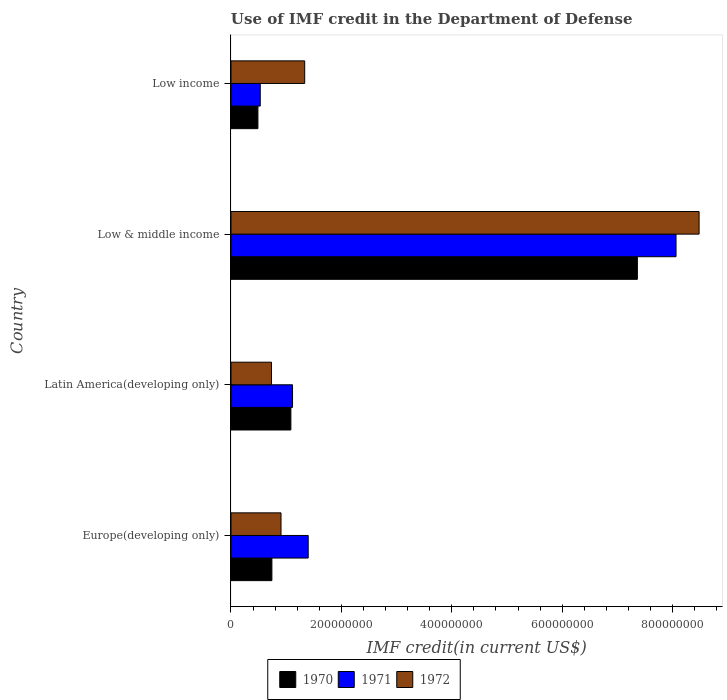How many different coloured bars are there?
Make the answer very short. 3. How many groups of bars are there?
Ensure brevity in your answer.  4. Are the number of bars on each tick of the Y-axis equal?
Your answer should be very brief. Yes. How many bars are there on the 2nd tick from the top?
Your response must be concise. 3. What is the label of the 4th group of bars from the top?
Your response must be concise. Europe(developing only). In how many cases, is the number of bars for a given country not equal to the number of legend labels?
Provide a succinct answer. 0. What is the IMF credit in the Department of Defense in 1970 in Low & middle income?
Your response must be concise. 7.36e+08. Across all countries, what is the maximum IMF credit in the Department of Defense in 1971?
Make the answer very short. 8.06e+08. Across all countries, what is the minimum IMF credit in the Department of Defense in 1971?
Give a very brief answer. 5.30e+07. In which country was the IMF credit in the Department of Defense in 1970 maximum?
Make the answer very short. Low & middle income. What is the total IMF credit in the Department of Defense in 1971 in the graph?
Provide a succinct answer. 1.11e+09. What is the difference between the IMF credit in the Department of Defense in 1971 in Latin America(developing only) and that in Low & middle income?
Provide a short and direct response. -6.95e+08. What is the difference between the IMF credit in the Department of Defense in 1970 in Europe(developing only) and the IMF credit in the Department of Defense in 1971 in Latin America(developing only)?
Your answer should be very brief. -3.74e+07. What is the average IMF credit in the Department of Defense in 1972 per country?
Offer a terse response. 2.86e+08. What is the difference between the IMF credit in the Department of Defense in 1972 and IMF credit in the Department of Defense in 1971 in Low & middle income?
Give a very brief answer. 4.18e+07. What is the ratio of the IMF credit in the Department of Defense in 1972 in Low & middle income to that in Low income?
Give a very brief answer. 6.35. Is the IMF credit in the Department of Defense in 1971 in Latin America(developing only) less than that in Low income?
Keep it short and to the point. No. Is the difference between the IMF credit in the Department of Defense in 1972 in Europe(developing only) and Low income greater than the difference between the IMF credit in the Department of Defense in 1971 in Europe(developing only) and Low income?
Keep it short and to the point. No. What is the difference between the highest and the second highest IMF credit in the Department of Defense in 1971?
Your answer should be compact. 6.66e+08. What is the difference between the highest and the lowest IMF credit in the Department of Defense in 1971?
Your answer should be compact. 7.53e+08. How many countries are there in the graph?
Provide a succinct answer. 4. Does the graph contain any zero values?
Provide a succinct answer. No. Does the graph contain grids?
Provide a succinct answer. No. How many legend labels are there?
Offer a terse response. 3. How are the legend labels stacked?
Ensure brevity in your answer.  Horizontal. What is the title of the graph?
Give a very brief answer. Use of IMF credit in the Department of Defense. What is the label or title of the X-axis?
Provide a short and direct response. IMF credit(in current US$). What is the IMF credit(in current US$) in 1970 in Europe(developing only)?
Ensure brevity in your answer.  7.41e+07. What is the IMF credit(in current US$) of 1971 in Europe(developing only)?
Your answer should be compact. 1.40e+08. What is the IMF credit(in current US$) of 1972 in Europe(developing only)?
Offer a terse response. 9.07e+07. What is the IMF credit(in current US$) in 1970 in Latin America(developing only)?
Give a very brief answer. 1.09e+08. What is the IMF credit(in current US$) in 1971 in Latin America(developing only)?
Provide a short and direct response. 1.12e+08. What is the IMF credit(in current US$) in 1972 in Latin America(developing only)?
Ensure brevity in your answer.  7.34e+07. What is the IMF credit(in current US$) of 1970 in Low & middle income?
Your answer should be compact. 7.36e+08. What is the IMF credit(in current US$) in 1971 in Low & middle income?
Provide a succinct answer. 8.06e+08. What is the IMF credit(in current US$) in 1972 in Low & middle income?
Ensure brevity in your answer.  8.48e+08. What is the IMF credit(in current US$) of 1970 in Low income?
Provide a short and direct response. 4.88e+07. What is the IMF credit(in current US$) of 1971 in Low income?
Give a very brief answer. 5.30e+07. What is the IMF credit(in current US$) of 1972 in Low income?
Provide a short and direct response. 1.34e+08. Across all countries, what is the maximum IMF credit(in current US$) of 1970?
Give a very brief answer. 7.36e+08. Across all countries, what is the maximum IMF credit(in current US$) of 1971?
Provide a short and direct response. 8.06e+08. Across all countries, what is the maximum IMF credit(in current US$) in 1972?
Provide a short and direct response. 8.48e+08. Across all countries, what is the minimum IMF credit(in current US$) of 1970?
Provide a short and direct response. 4.88e+07. Across all countries, what is the minimum IMF credit(in current US$) in 1971?
Make the answer very short. 5.30e+07. Across all countries, what is the minimum IMF credit(in current US$) of 1972?
Your response must be concise. 7.34e+07. What is the total IMF credit(in current US$) of 1970 in the graph?
Offer a terse response. 9.68e+08. What is the total IMF credit(in current US$) of 1971 in the graph?
Provide a short and direct response. 1.11e+09. What is the total IMF credit(in current US$) of 1972 in the graph?
Make the answer very short. 1.15e+09. What is the difference between the IMF credit(in current US$) in 1970 in Europe(developing only) and that in Latin America(developing only)?
Offer a very short reply. -3.44e+07. What is the difference between the IMF credit(in current US$) of 1971 in Europe(developing only) and that in Latin America(developing only)?
Provide a short and direct response. 2.84e+07. What is the difference between the IMF credit(in current US$) in 1972 in Europe(developing only) and that in Latin America(developing only)?
Keep it short and to the point. 1.72e+07. What is the difference between the IMF credit(in current US$) of 1970 in Europe(developing only) and that in Low & middle income?
Give a very brief answer. -6.62e+08. What is the difference between the IMF credit(in current US$) of 1971 in Europe(developing only) and that in Low & middle income?
Provide a short and direct response. -6.66e+08. What is the difference between the IMF credit(in current US$) in 1972 in Europe(developing only) and that in Low & middle income?
Make the answer very short. -7.57e+08. What is the difference between the IMF credit(in current US$) in 1970 in Europe(developing only) and that in Low income?
Provide a succinct answer. 2.53e+07. What is the difference between the IMF credit(in current US$) in 1971 in Europe(developing only) and that in Low income?
Your answer should be very brief. 8.69e+07. What is the difference between the IMF credit(in current US$) of 1972 in Europe(developing only) and that in Low income?
Give a very brief answer. -4.29e+07. What is the difference between the IMF credit(in current US$) of 1970 in Latin America(developing only) and that in Low & middle income?
Your answer should be very brief. -6.28e+08. What is the difference between the IMF credit(in current US$) of 1971 in Latin America(developing only) and that in Low & middle income?
Give a very brief answer. -6.95e+08. What is the difference between the IMF credit(in current US$) of 1972 in Latin America(developing only) and that in Low & middle income?
Your answer should be very brief. -7.75e+08. What is the difference between the IMF credit(in current US$) of 1970 in Latin America(developing only) and that in Low income?
Keep it short and to the point. 5.97e+07. What is the difference between the IMF credit(in current US$) of 1971 in Latin America(developing only) and that in Low income?
Ensure brevity in your answer.  5.85e+07. What is the difference between the IMF credit(in current US$) in 1972 in Latin America(developing only) and that in Low income?
Your answer should be very brief. -6.01e+07. What is the difference between the IMF credit(in current US$) of 1970 in Low & middle income and that in Low income?
Offer a very short reply. 6.87e+08. What is the difference between the IMF credit(in current US$) in 1971 in Low & middle income and that in Low income?
Ensure brevity in your answer.  7.53e+08. What is the difference between the IMF credit(in current US$) in 1972 in Low & middle income and that in Low income?
Your response must be concise. 7.14e+08. What is the difference between the IMF credit(in current US$) in 1970 in Europe(developing only) and the IMF credit(in current US$) in 1971 in Latin America(developing only)?
Offer a terse response. -3.74e+07. What is the difference between the IMF credit(in current US$) of 1970 in Europe(developing only) and the IMF credit(in current US$) of 1972 in Latin America(developing only)?
Offer a very short reply. 7.05e+05. What is the difference between the IMF credit(in current US$) in 1971 in Europe(developing only) and the IMF credit(in current US$) in 1972 in Latin America(developing only)?
Provide a short and direct response. 6.65e+07. What is the difference between the IMF credit(in current US$) in 1970 in Europe(developing only) and the IMF credit(in current US$) in 1971 in Low & middle income?
Offer a terse response. -7.32e+08. What is the difference between the IMF credit(in current US$) in 1970 in Europe(developing only) and the IMF credit(in current US$) in 1972 in Low & middle income?
Keep it short and to the point. -7.74e+08. What is the difference between the IMF credit(in current US$) in 1971 in Europe(developing only) and the IMF credit(in current US$) in 1972 in Low & middle income?
Offer a very short reply. -7.08e+08. What is the difference between the IMF credit(in current US$) in 1970 in Europe(developing only) and the IMF credit(in current US$) in 1971 in Low income?
Offer a very short reply. 2.11e+07. What is the difference between the IMF credit(in current US$) of 1970 in Europe(developing only) and the IMF credit(in current US$) of 1972 in Low income?
Offer a terse response. -5.94e+07. What is the difference between the IMF credit(in current US$) of 1971 in Europe(developing only) and the IMF credit(in current US$) of 1972 in Low income?
Your answer should be very brief. 6.35e+06. What is the difference between the IMF credit(in current US$) in 1970 in Latin America(developing only) and the IMF credit(in current US$) in 1971 in Low & middle income?
Make the answer very short. -6.98e+08. What is the difference between the IMF credit(in current US$) of 1970 in Latin America(developing only) and the IMF credit(in current US$) of 1972 in Low & middle income?
Keep it short and to the point. -7.40e+08. What is the difference between the IMF credit(in current US$) in 1971 in Latin America(developing only) and the IMF credit(in current US$) in 1972 in Low & middle income?
Your answer should be very brief. -7.37e+08. What is the difference between the IMF credit(in current US$) of 1970 in Latin America(developing only) and the IMF credit(in current US$) of 1971 in Low income?
Your answer should be compact. 5.55e+07. What is the difference between the IMF credit(in current US$) in 1970 in Latin America(developing only) and the IMF credit(in current US$) in 1972 in Low income?
Your answer should be compact. -2.50e+07. What is the difference between the IMF credit(in current US$) in 1971 in Latin America(developing only) and the IMF credit(in current US$) in 1972 in Low income?
Ensure brevity in your answer.  -2.20e+07. What is the difference between the IMF credit(in current US$) of 1970 in Low & middle income and the IMF credit(in current US$) of 1971 in Low income?
Provide a succinct answer. 6.83e+08. What is the difference between the IMF credit(in current US$) of 1970 in Low & middle income and the IMF credit(in current US$) of 1972 in Low income?
Keep it short and to the point. 6.03e+08. What is the difference between the IMF credit(in current US$) of 1971 in Low & middle income and the IMF credit(in current US$) of 1972 in Low income?
Your answer should be compact. 6.73e+08. What is the average IMF credit(in current US$) of 1970 per country?
Provide a short and direct response. 2.42e+08. What is the average IMF credit(in current US$) of 1971 per country?
Provide a short and direct response. 2.78e+08. What is the average IMF credit(in current US$) in 1972 per country?
Make the answer very short. 2.86e+08. What is the difference between the IMF credit(in current US$) of 1970 and IMF credit(in current US$) of 1971 in Europe(developing only)?
Ensure brevity in your answer.  -6.58e+07. What is the difference between the IMF credit(in current US$) of 1970 and IMF credit(in current US$) of 1972 in Europe(developing only)?
Ensure brevity in your answer.  -1.65e+07. What is the difference between the IMF credit(in current US$) of 1971 and IMF credit(in current US$) of 1972 in Europe(developing only)?
Make the answer very short. 4.93e+07. What is the difference between the IMF credit(in current US$) of 1970 and IMF credit(in current US$) of 1971 in Latin America(developing only)?
Offer a very short reply. -3.01e+06. What is the difference between the IMF credit(in current US$) in 1970 and IMF credit(in current US$) in 1972 in Latin America(developing only)?
Offer a terse response. 3.51e+07. What is the difference between the IMF credit(in current US$) of 1971 and IMF credit(in current US$) of 1972 in Latin America(developing only)?
Your response must be concise. 3.81e+07. What is the difference between the IMF credit(in current US$) in 1970 and IMF credit(in current US$) in 1971 in Low & middle income?
Offer a terse response. -7.00e+07. What is the difference between the IMF credit(in current US$) in 1970 and IMF credit(in current US$) in 1972 in Low & middle income?
Keep it short and to the point. -1.12e+08. What is the difference between the IMF credit(in current US$) of 1971 and IMF credit(in current US$) of 1972 in Low & middle income?
Offer a terse response. -4.18e+07. What is the difference between the IMF credit(in current US$) of 1970 and IMF credit(in current US$) of 1971 in Low income?
Offer a very short reply. -4.21e+06. What is the difference between the IMF credit(in current US$) in 1970 and IMF credit(in current US$) in 1972 in Low income?
Provide a short and direct response. -8.47e+07. What is the difference between the IMF credit(in current US$) in 1971 and IMF credit(in current US$) in 1972 in Low income?
Ensure brevity in your answer.  -8.05e+07. What is the ratio of the IMF credit(in current US$) of 1970 in Europe(developing only) to that in Latin America(developing only)?
Offer a terse response. 0.68. What is the ratio of the IMF credit(in current US$) in 1971 in Europe(developing only) to that in Latin America(developing only)?
Ensure brevity in your answer.  1.25. What is the ratio of the IMF credit(in current US$) of 1972 in Europe(developing only) to that in Latin America(developing only)?
Your answer should be very brief. 1.23. What is the ratio of the IMF credit(in current US$) of 1970 in Europe(developing only) to that in Low & middle income?
Your response must be concise. 0.1. What is the ratio of the IMF credit(in current US$) of 1971 in Europe(developing only) to that in Low & middle income?
Offer a very short reply. 0.17. What is the ratio of the IMF credit(in current US$) in 1972 in Europe(developing only) to that in Low & middle income?
Offer a terse response. 0.11. What is the ratio of the IMF credit(in current US$) in 1970 in Europe(developing only) to that in Low income?
Provide a short and direct response. 1.52. What is the ratio of the IMF credit(in current US$) of 1971 in Europe(developing only) to that in Low income?
Your answer should be compact. 2.64. What is the ratio of the IMF credit(in current US$) in 1972 in Europe(developing only) to that in Low income?
Provide a short and direct response. 0.68. What is the ratio of the IMF credit(in current US$) in 1970 in Latin America(developing only) to that in Low & middle income?
Offer a terse response. 0.15. What is the ratio of the IMF credit(in current US$) in 1971 in Latin America(developing only) to that in Low & middle income?
Give a very brief answer. 0.14. What is the ratio of the IMF credit(in current US$) in 1972 in Latin America(developing only) to that in Low & middle income?
Offer a very short reply. 0.09. What is the ratio of the IMF credit(in current US$) in 1970 in Latin America(developing only) to that in Low income?
Make the answer very short. 2.22. What is the ratio of the IMF credit(in current US$) in 1971 in Latin America(developing only) to that in Low income?
Provide a succinct answer. 2.1. What is the ratio of the IMF credit(in current US$) in 1972 in Latin America(developing only) to that in Low income?
Give a very brief answer. 0.55. What is the ratio of the IMF credit(in current US$) in 1970 in Low & middle income to that in Low income?
Offer a very short reply. 15.08. What is the ratio of the IMF credit(in current US$) in 1971 in Low & middle income to that in Low income?
Keep it short and to the point. 15.21. What is the ratio of the IMF credit(in current US$) of 1972 in Low & middle income to that in Low income?
Provide a short and direct response. 6.35. What is the difference between the highest and the second highest IMF credit(in current US$) in 1970?
Keep it short and to the point. 6.28e+08. What is the difference between the highest and the second highest IMF credit(in current US$) in 1971?
Ensure brevity in your answer.  6.66e+08. What is the difference between the highest and the second highest IMF credit(in current US$) of 1972?
Your response must be concise. 7.14e+08. What is the difference between the highest and the lowest IMF credit(in current US$) in 1970?
Offer a very short reply. 6.87e+08. What is the difference between the highest and the lowest IMF credit(in current US$) of 1971?
Your answer should be very brief. 7.53e+08. What is the difference between the highest and the lowest IMF credit(in current US$) in 1972?
Provide a short and direct response. 7.75e+08. 